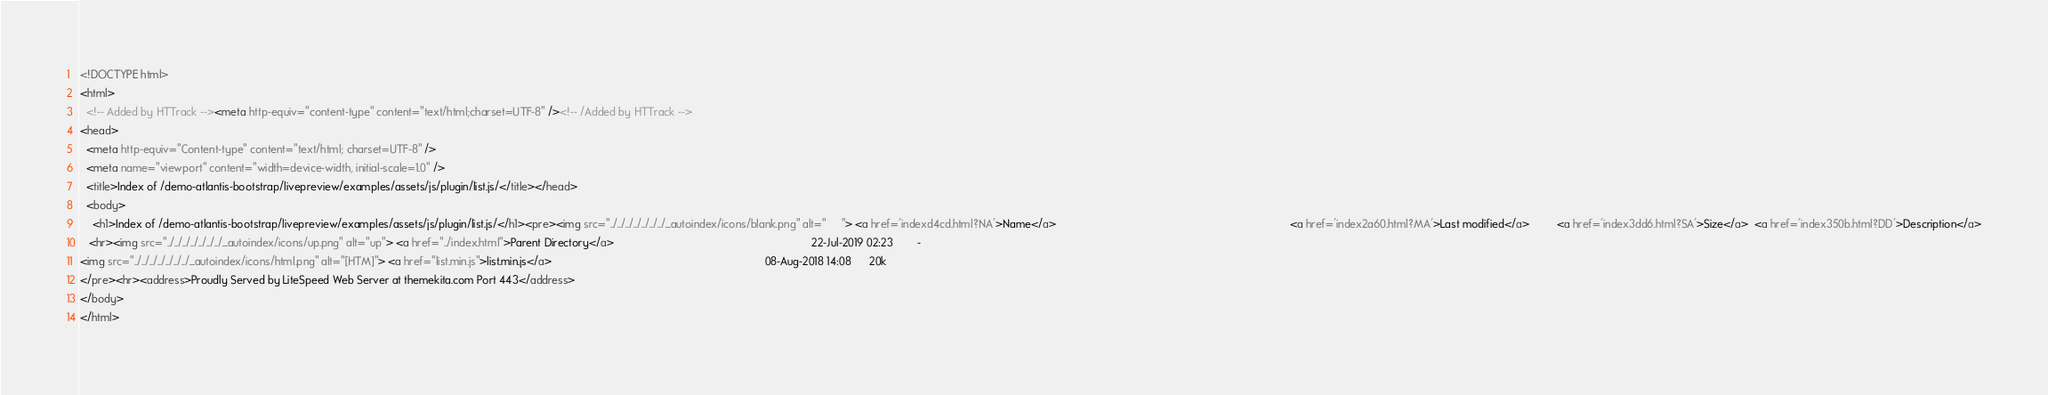Convert code to text. <code><loc_0><loc_0><loc_500><loc_500><_HTML_><!DOCTYPE html>
<html>
  <!-- Added by HTTrack --><meta http-equiv="content-type" content="text/html;charset=UTF-8" /><!-- /Added by HTTrack -->
<head>
  <meta http-equiv="Content-type" content="text/html; charset=UTF-8" />
  <meta name="viewport" content="width=device-width, initial-scale=1.0" />
  <title>Index of /demo-atlantis-bootstrap/livepreview/examples/assets/js/plugin/list.js/</title></head>
  <body>
    <h1>Index of /demo-atlantis-bootstrap/livepreview/examples/assets/js/plugin/list.js/</h1><pre><img src="../../../../../../../_autoindex/icons/blank.png" alt="     "> <a href='indexd4cd.html?NA'>Name</a>                                                                             <a href='index2a60.html?MA'>Last modified</a>         <a href='index3dd6.html?SA'>Size</a>  <a href='index350b.html?DD'>Description</a>
   <hr><img src="../../../../../../../_autoindex/icons/up.png" alt="up"> <a href="../index.html">Parent Directory</a>                                                                 22-Jul-2019 02:23        -       
<img src="../../../../../../../_autoindex/icons/html.png" alt="[HTM]"> <a href="list.min.js">list.min.js</a>                                                                      08-Aug-2018 14:08      20k       
</pre><hr><address>Proudly Served by LiteSpeed Web Server at themekita.com Port 443</address>
</body>
</html></code> 